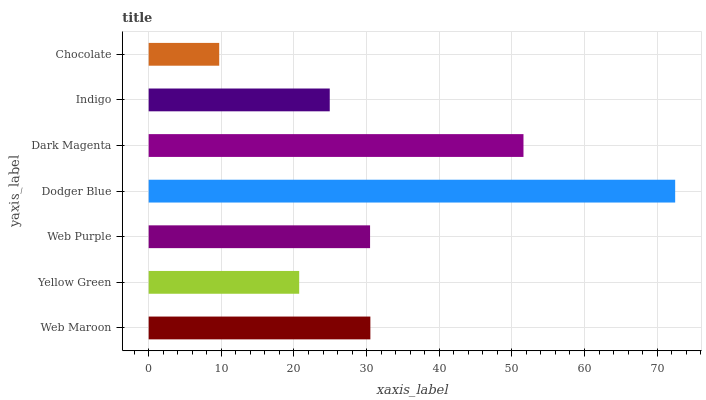Is Chocolate the minimum?
Answer yes or no. Yes. Is Dodger Blue the maximum?
Answer yes or no. Yes. Is Yellow Green the minimum?
Answer yes or no. No. Is Yellow Green the maximum?
Answer yes or no. No. Is Web Maroon greater than Yellow Green?
Answer yes or no. Yes. Is Yellow Green less than Web Maroon?
Answer yes or no. Yes. Is Yellow Green greater than Web Maroon?
Answer yes or no. No. Is Web Maroon less than Yellow Green?
Answer yes or no. No. Is Web Purple the high median?
Answer yes or no. Yes. Is Web Purple the low median?
Answer yes or no. Yes. Is Dodger Blue the high median?
Answer yes or no. No. Is Indigo the low median?
Answer yes or no. No. 